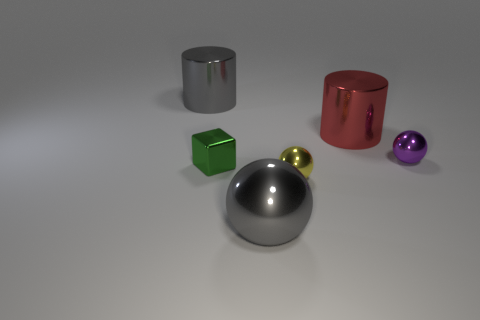There is a yellow thing that is the same shape as the purple metal object; what is its size?
Provide a succinct answer. Small. Are there more small yellow balls that are in front of the tiny shiny cube than things behind the purple shiny object?
Provide a short and direct response. No. Is the material of the gray cylinder the same as the object that is to the right of the red shiny thing?
Your answer should be very brief. Yes. Is there any other thing that has the same shape as the large red shiny object?
Keep it short and to the point. Yes. The tiny metallic object that is both to the left of the purple object and right of the green thing is what color?
Make the answer very short. Yellow. What shape is the gray object that is behind the tiny yellow thing?
Offer a terse response. Cylinder. What size is the cylinder right of the big gray metallic object that is in front of the large gray metallic thing behind the purple sphere?
Your answer should be compact. Large. How many metallic balls are to the left of the tiny thing behind the tiny block?
Give a very brief answer. 2. What is the size of the shiny thing that is behind the block and left of the big gray metal sphere?
Make the answer very short. Large. What number of matte things are large gray spheres or blue things?
Ensure brevity in your answer.  0. 